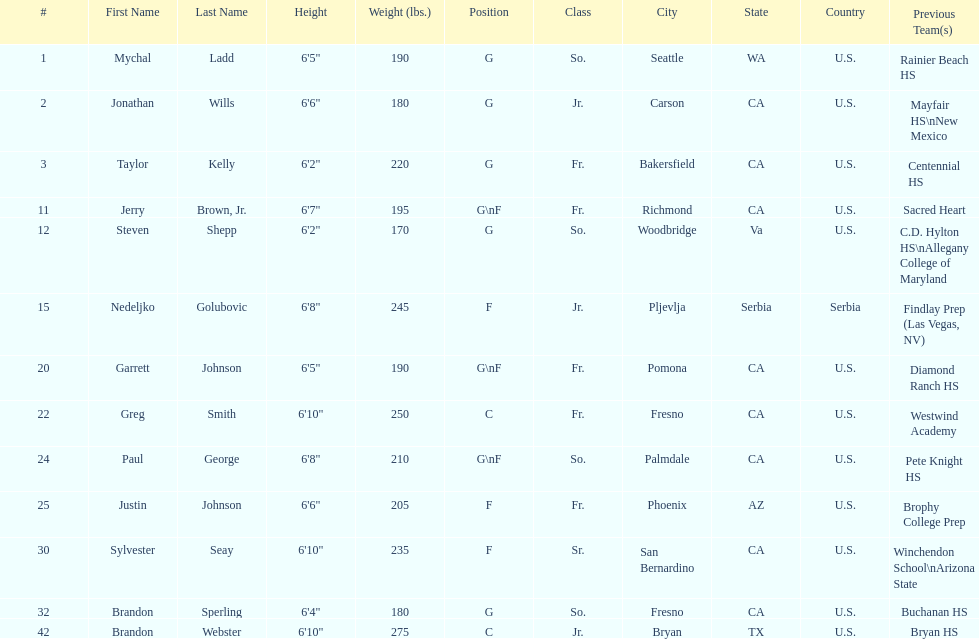Which positions are so.? G, G, G\nF, G. Which weights are g 190, 170, 180. What height is under 6 3' 6'2". What is the name Steven Shepp. 